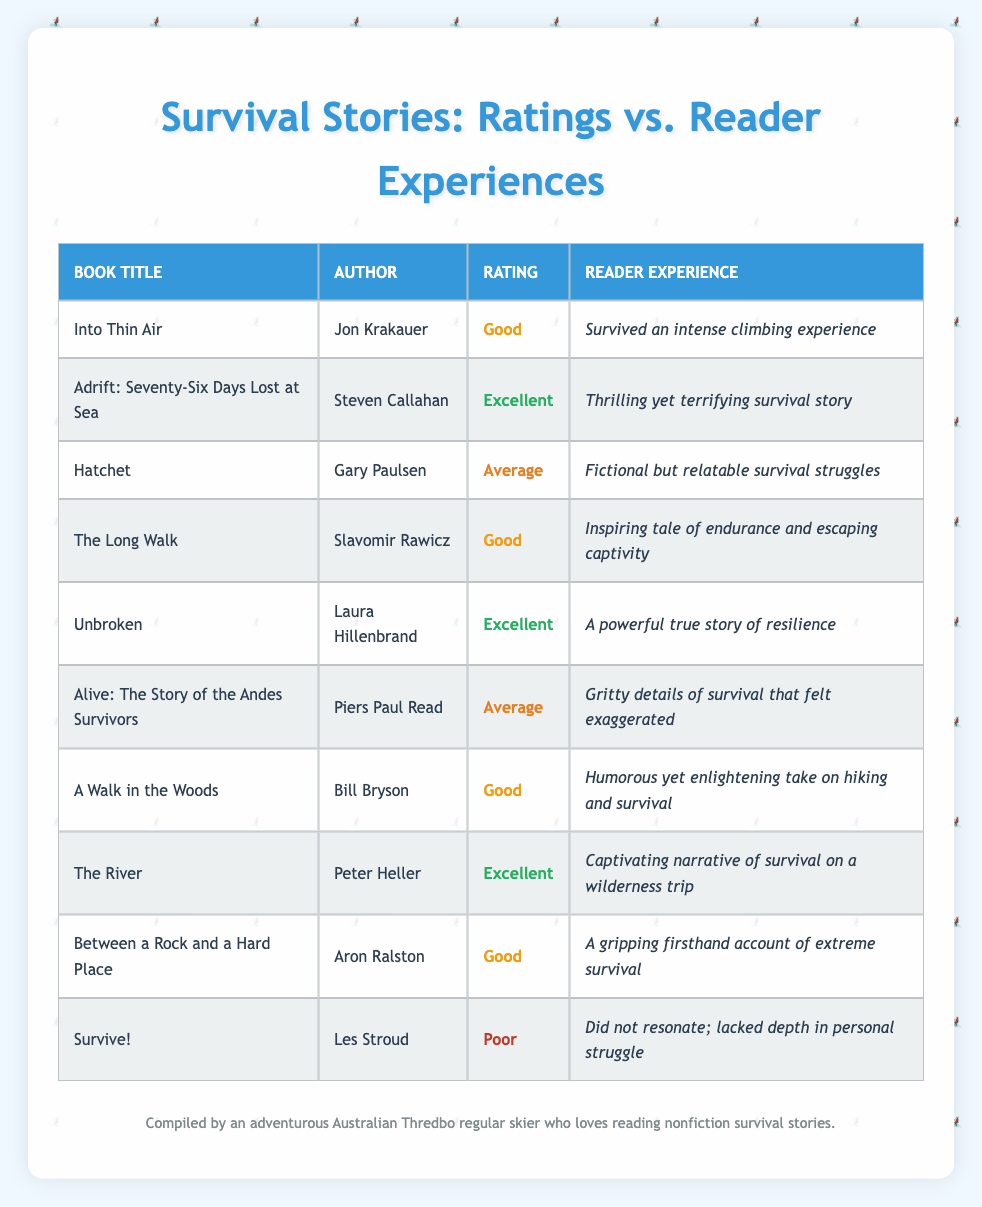What rating did the book "Alive: The Story of the Andes Survivors" receive? The table shows that "Alive: The Story of the Andes Survivors" is rated as "Average".
Answer: Average How many books were rated as "Excellent"? By counting the rows in the table, there are 3 books with the rating "Excellent": "Adrift: Seventy-Six Days Lost at Sea", "Unbroken", and "The River".
Answer: 3 Did any book rated "Poor" have a positive reader experience? The table indicates that "Survive!" is the only book rated "Poor", and its reader experience described it as lacking depth and not resonating, which is negative. Therefore, no book rated "Poor" had a positive reader experience.
Answer: No What is the average rating of the books that are categorized as "Good"? There are 4 books rated "Good": "Into Thin Air", "The Long Walk", "A Walk in the Woods", and "Between a Rock and a Hard Place". Since all are rated "Good", the average also remains "Good".
Answer: Good Which author has written a book rated "Average", and what is the book title? The table lists "Hatchet" by Gary Paulsen and "Alive: The Story of the Andes Survivors" by Piers Paul Read as books rated "Average".
Answer: Hatchet by Gary Paulsen, Alive: The Story of the Andes Survivors by Piers Paul Read Which book has the most positive reader experience and what was its rating? The book "Unbroken" by Laura Hillenbrand is rated "Excellent" and has a powerful true story of resilience as its reader experience, reflecting a very positive impression.
Answer: Unbroken, Excellent 